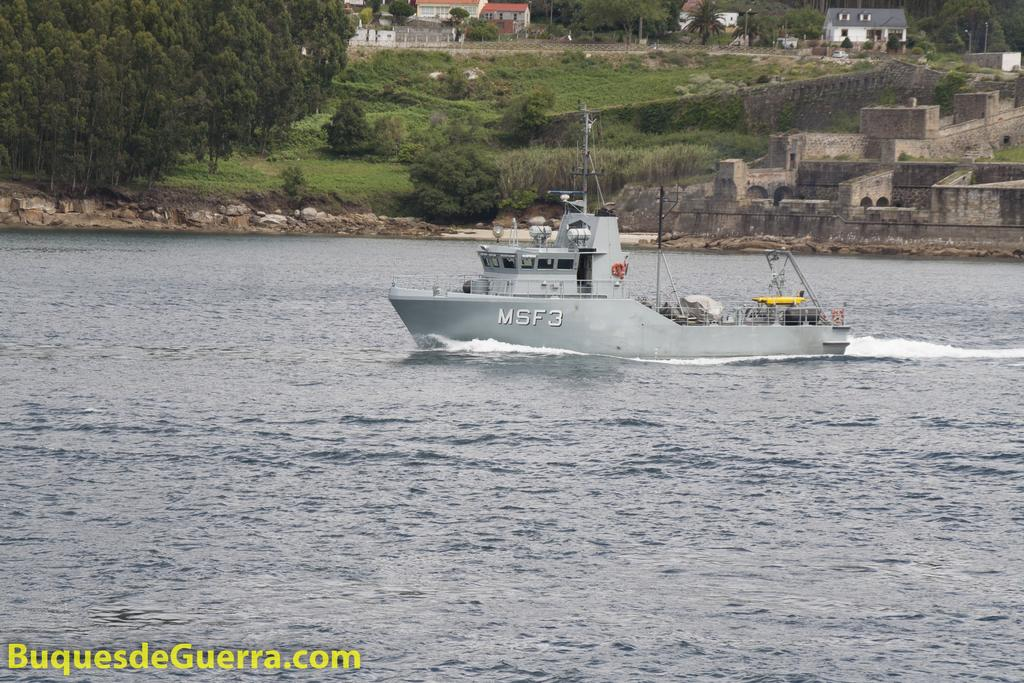What is the main subject of the image? The main subject of the image is a boat. Where is the boat located? The boat is on the water. What can be seen in the background of the image? In the background of the image, there are poles, buildings, and trees. Is there any text present in the image? Yes, there is some text at the left bottom of the image. How many worms can be seen crawling on the boat in the image? There are no worms present in the image; the boat is on the water, and there are no worms visible. 